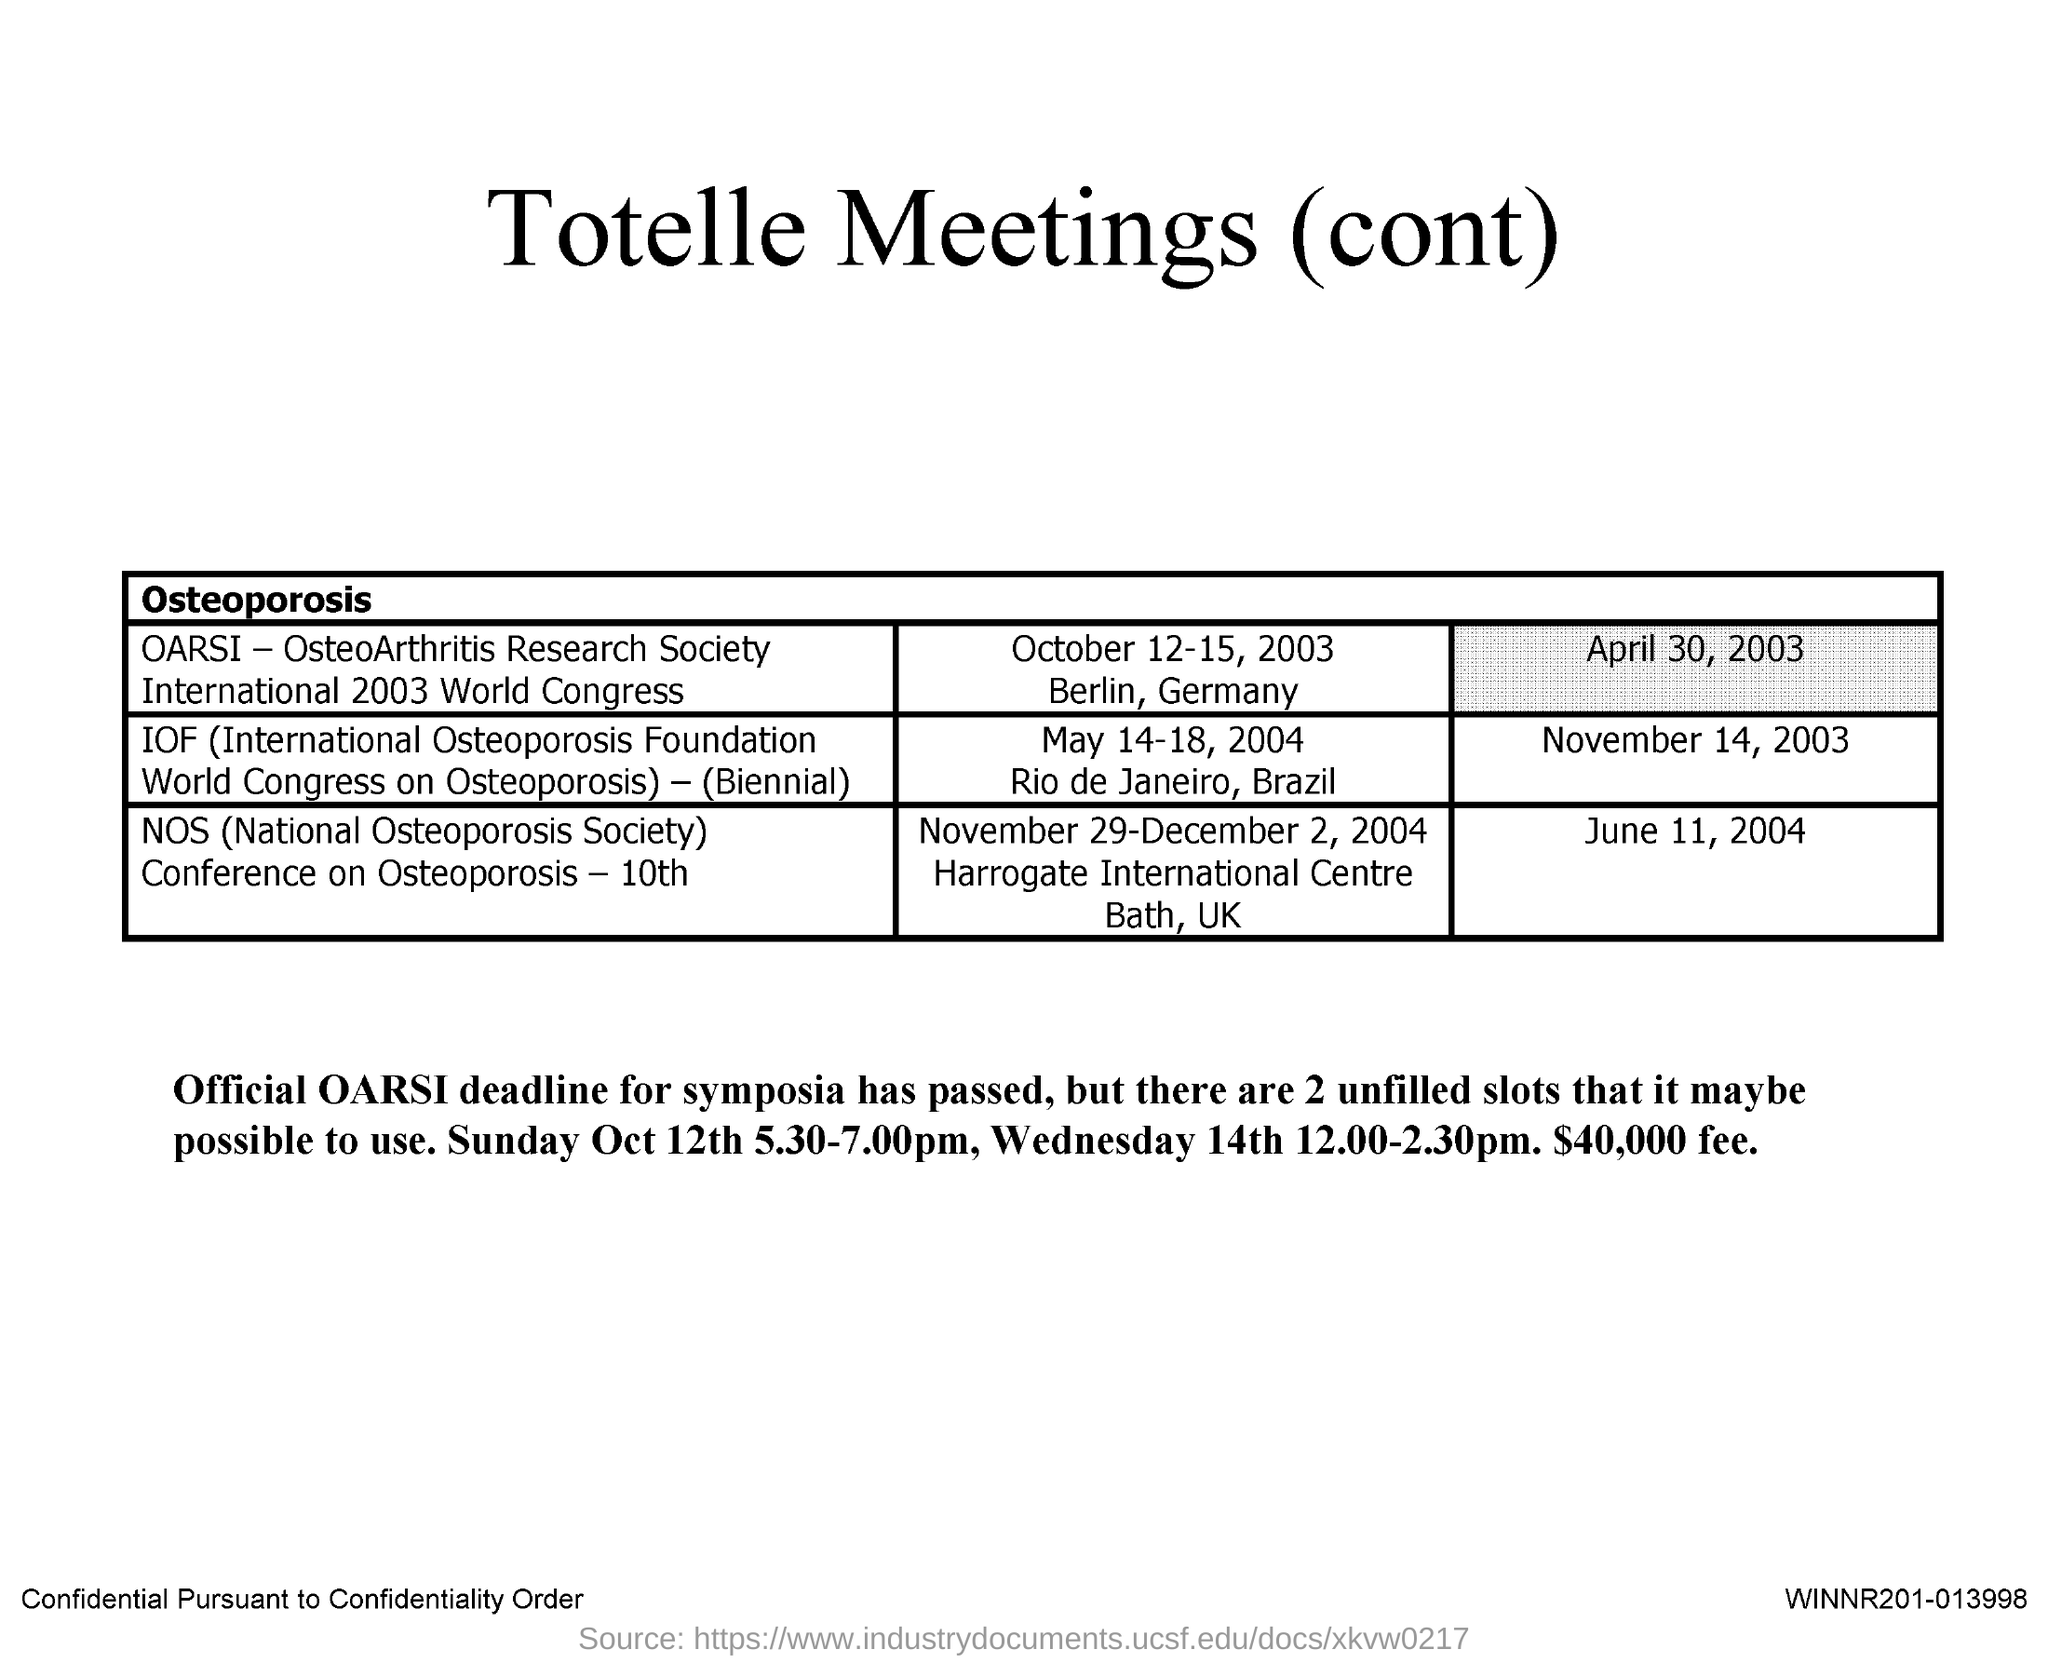Indicate a few pertinent items in this graphic. The full form of IOF is the International Osteoporosis Foundation. The abbreviation for NOS is National Osteoporosis Society. 